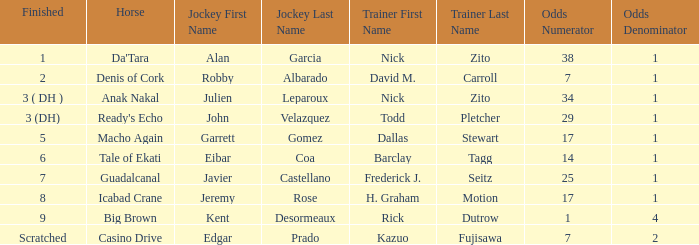Which Horse finished in 8? Icabad Crane. Could you parse the entire table? {'header': ['Finished', 'Horse', 'Jockey First Name', 'Jockey Last Name', 'Trainer First Name', 'Trainer Last Name', 'Odds Numerator', 'Odds Denominator'], 'rows': [['1', "Da'Tara", 'Alan', 'Garcia', 'Nick', 'Zito', '38', '1'], ['2', 'Denis of Cork', 'Robby', 'Albarado', 'David M.', 'Carroll', '7', '1'], ['3 ( DH )', 'Anak Nakal', 'Julien', 'Leparoux', 'Nick', 'Zito', '34', '1'], ['3 (DH)', "Ready's Echo", 'John', 'Velazquez', 'Todd', 'Pletcher', '29', '1'], ['5', 'Macho Again', 'Garrett', 'Gomez', 'Dallas', 'Stewart', '17', '1'], ['6', 'Tale of Ekati', 'Eibar', 'Coa', 'Barclay', 'Tagg', '14', '1'], ['7', 'Guadalcanal', 'Javier', 'Castellano', 'Frederick J.', 'Seitz', '25', '1'], ['8', 'Icabad Crane', 'Jeremy', 'Rose', 'H. Graham', 'Motion', '17', '1'], ['9', 'Big Brown', 'Kent', 'Desormeaux', 'Rick', 'Dutrow', '1', '4'], ['Scratched', 'Casino Drive', 'Edgar', 'Prado', 'Kazuo', 'Fujisawa', '7', '2']]} 